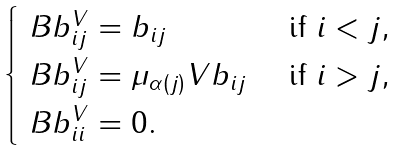Convert formula to latex. <formula><loc_0><loc_0><loc_500><loc_500>\begin{cases} \ B b _ { i j } ^ { V } = b _ { i j } & \text { if } i < j , \\ \ B b _ { i j } ^ { V } = \mu _ { \alpha ( j ) } V b _ { i j } & \text { if } i > j , \\ \ B b _ { i i } ^ { V } = 0 . \end{cases}</formula> 